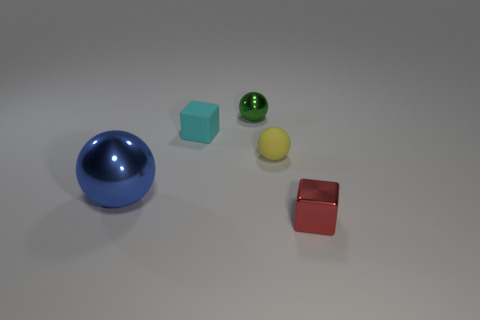Add 2 red cubes. How many objects exist? 7 Subtract all balls. How many objects are left? 2 Add 5 tiny shiny balls. How many tiny shiny balls are left? 6 Add 3 big green matte things. How many big green matte things exist? 3 Subtract 0 red cylinders. How many objects are left? 5 Subtract all big blue rubber cubes. Subtract all red metallic things. How many objects are left? 4 